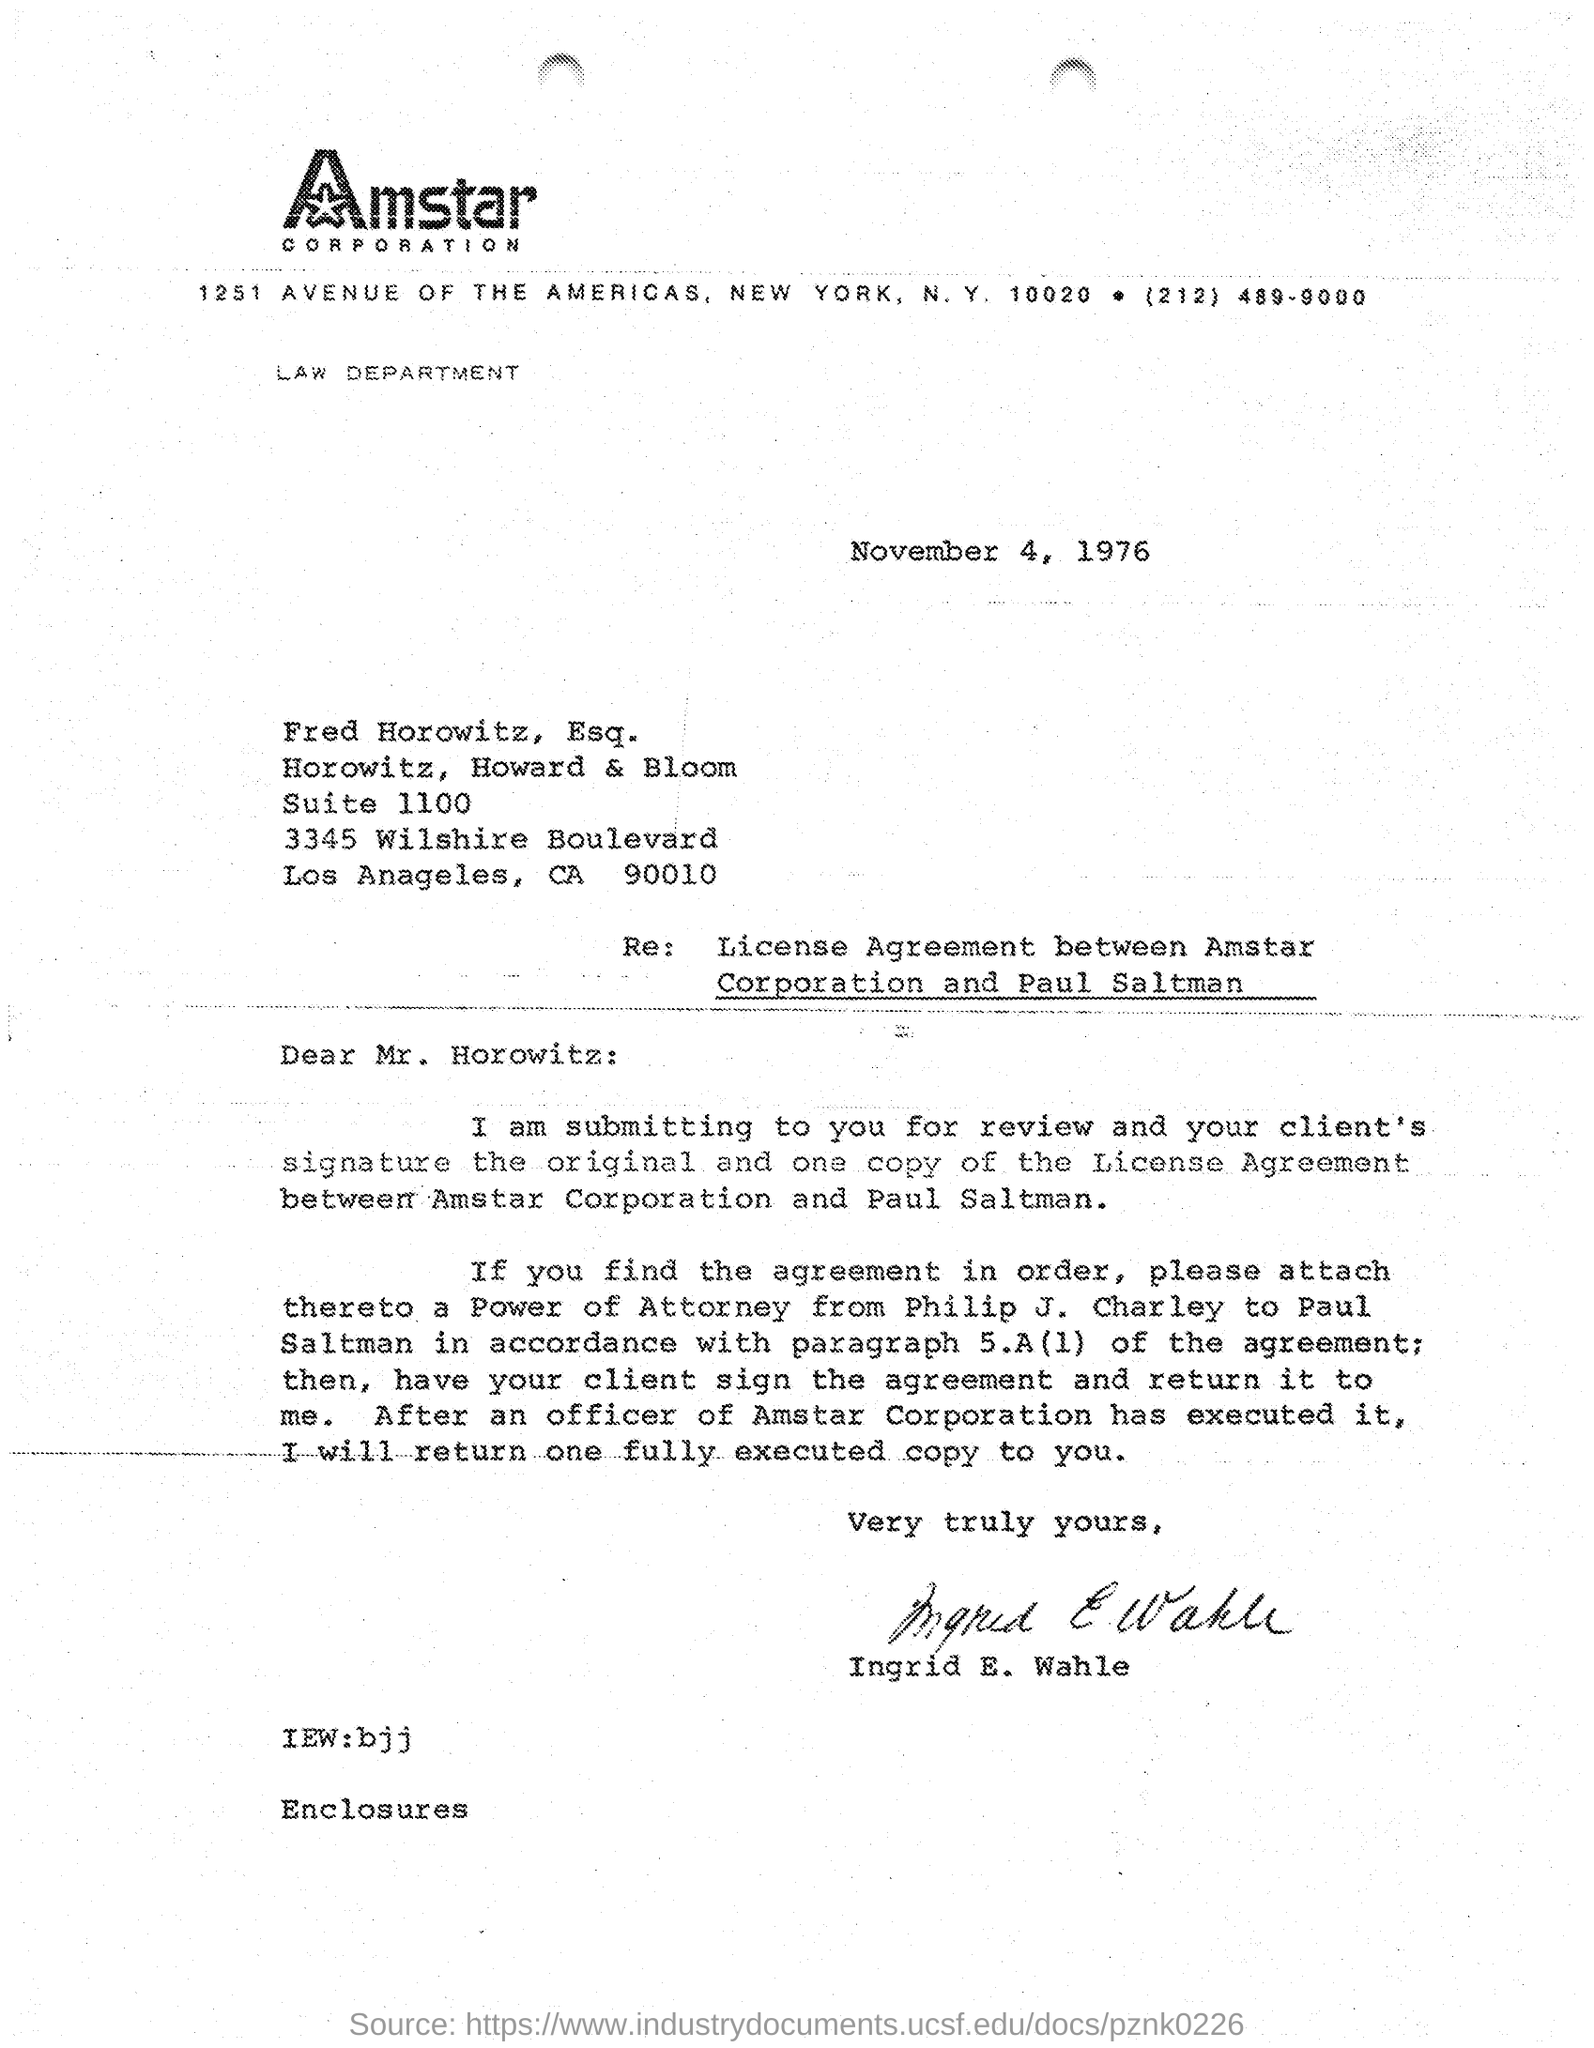Which company is mentioned in the letter head?
Offer a very short reply. Amstar corporation. What is the issued date of this letter?
Make the answer very short. November 4, 1976. Who has signed this letter?
Give a very brief answer. Ingrid E. Wahle. 